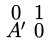<formula> <loc_0><loc_0><loc_500><loc_500>\begin{smallmatrix} 0 & 1 \\ A ^ { \prime } & 0 \end{smallmatrix}</formula> 